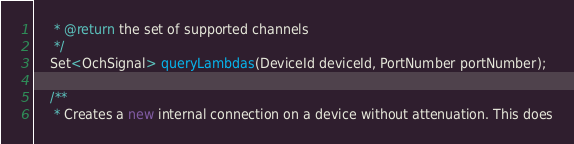Convert code to text. <code><loc_0><loc_0><loc_500><loc_500><_Java_>     * @return the set of supported channels
     */
    Set<OchSignal> queryLambdas(DeviceId deviceId, PortNumber portNumber);

    /**
     * Creates a new internal connection on a device without attenuation. This does</code> 